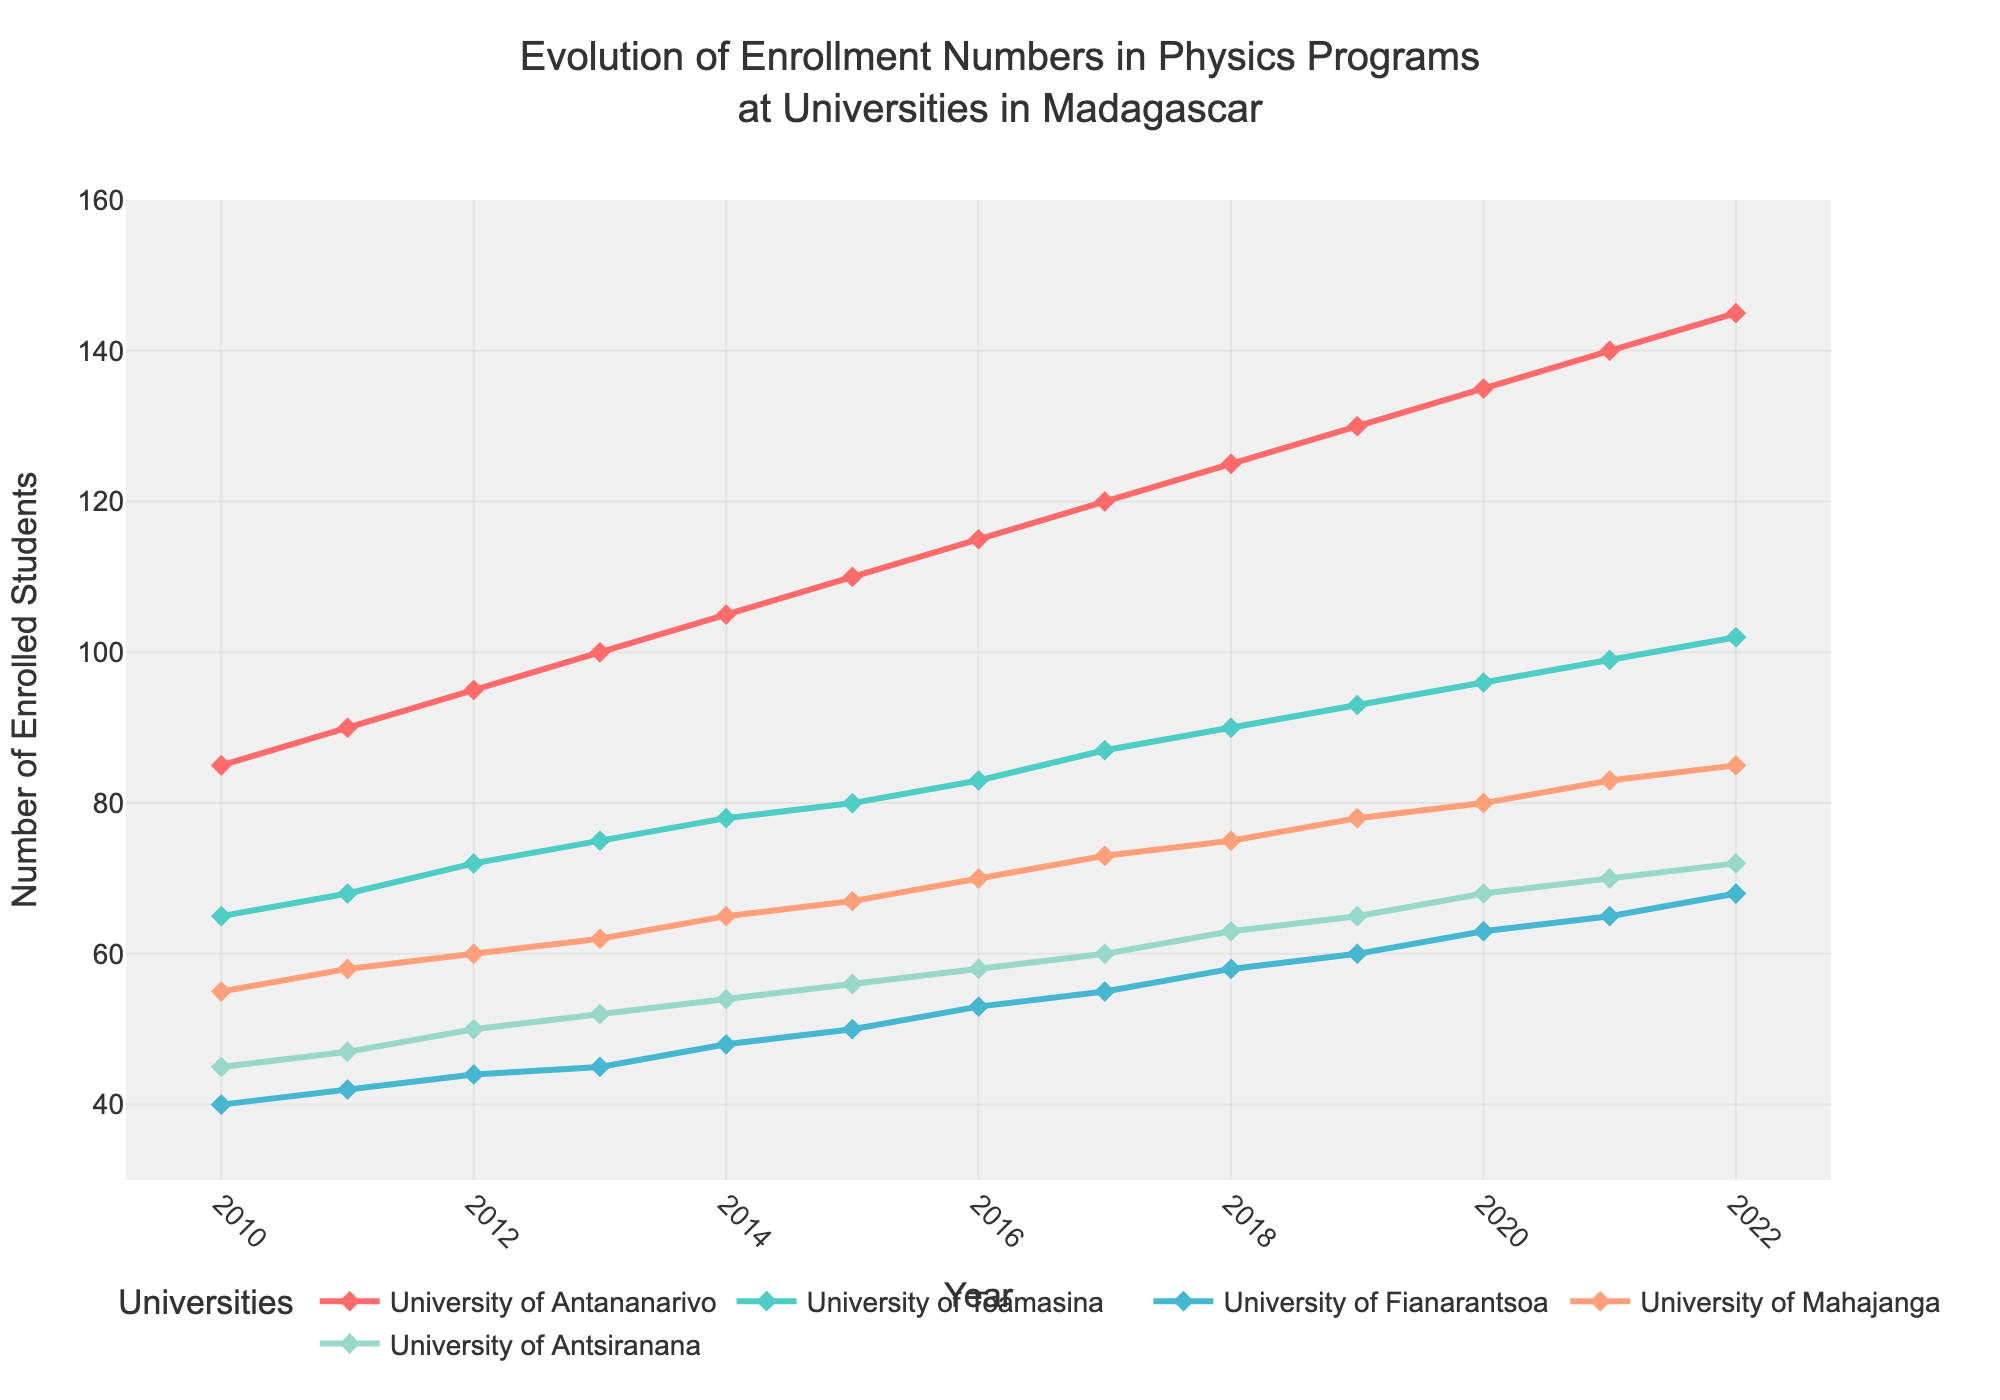What is the title of the figure? The title of the figure is located at the top center of the plot. It reads "Evolution of Enrollment Numbers in Physics Programs at Universities in Madagascar".
Answer: Evolution of Enrollment Numbers in Physics Programs at Universities in Madagascar How many universities are shown in the figure? Count the number of distinct traces (or lines) representing different universities in the plot.
Answer: 5 Which university had the highest enrollment in 2022? Look at the endpoints of all lines in 2022 and identify the one with the highest value.
Answer: University of Antananarivo What was the enrollment number for the University of Mahajanga in 2015? Find the data point on the line representing the University of Mahajanga for the year 2015.
Answer: 67 Which university saw the largest increase in enrollment numbers from 2010 to 2022? Calculate the difference between the enrollment numbers in 2022 and 2010 for each university, then compare these differences.
Answer: University of Antananarivo What's the average enrollment in 2020 across all five universities? Add the enrollment numbers for all five universities in 2020, then divide by 5 to find the average. (135 + 96 + 63 + 80 + 68) / 5 = 442 / 5 = 88.4
Answer: 88.4 Did any university see a decline in enrollment at any point between 2010 and 2022? Examine the line plots for each university and check if any line moves downward at any point.
Answer: No Which year showed the maximum enrollment number for the University of Fianarantsoa? Identify the highest point on the line representing the University of Fianarantsoa and note the corresponding year.
Answer: 2022 Compare the enrollment numbers between University of Toamasina and University of Antsiranana in 2014. Which one had more students? Look at the data points for the year 2014 for both universities and compare their enrollment numbers.
Answer: University of Toamasina What was the overall trend in enrollment numbers at the University of Antananarivo over the years? Follow the line for the University of Antananarivo from 2010 to 2022 and describe the general direction it takes.
Answer: Increasing 